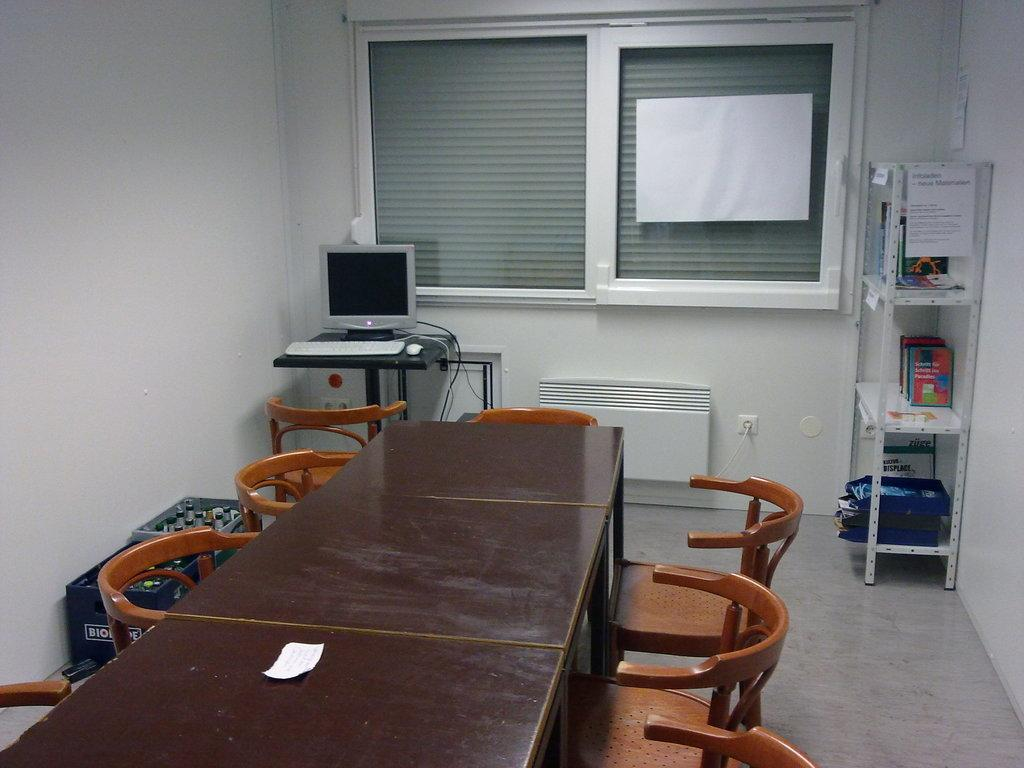What is on the table in the image? There is a monitor on a table in the image. What type of furniture is present in the image? There are chairs in the image. What can be seen on the wall or in the background of the image? There is a bookshelf visible in the image. What type of salt is sprinkled on the coil in the image? There is no salt or coil present in the image. How does the skin on the person's hand look in the image? There is no person or hand visible in the image. 